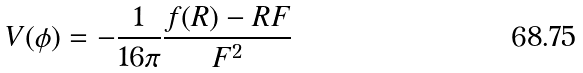Convert formula to latex. <formula><loc_0><loc_0><loc_500><loc_500>V ( \phi ) = - \frac { 1 } { 1 6 \pi } \frac { f ( R ) - R F } { F ^ { 2 } }</formula> 